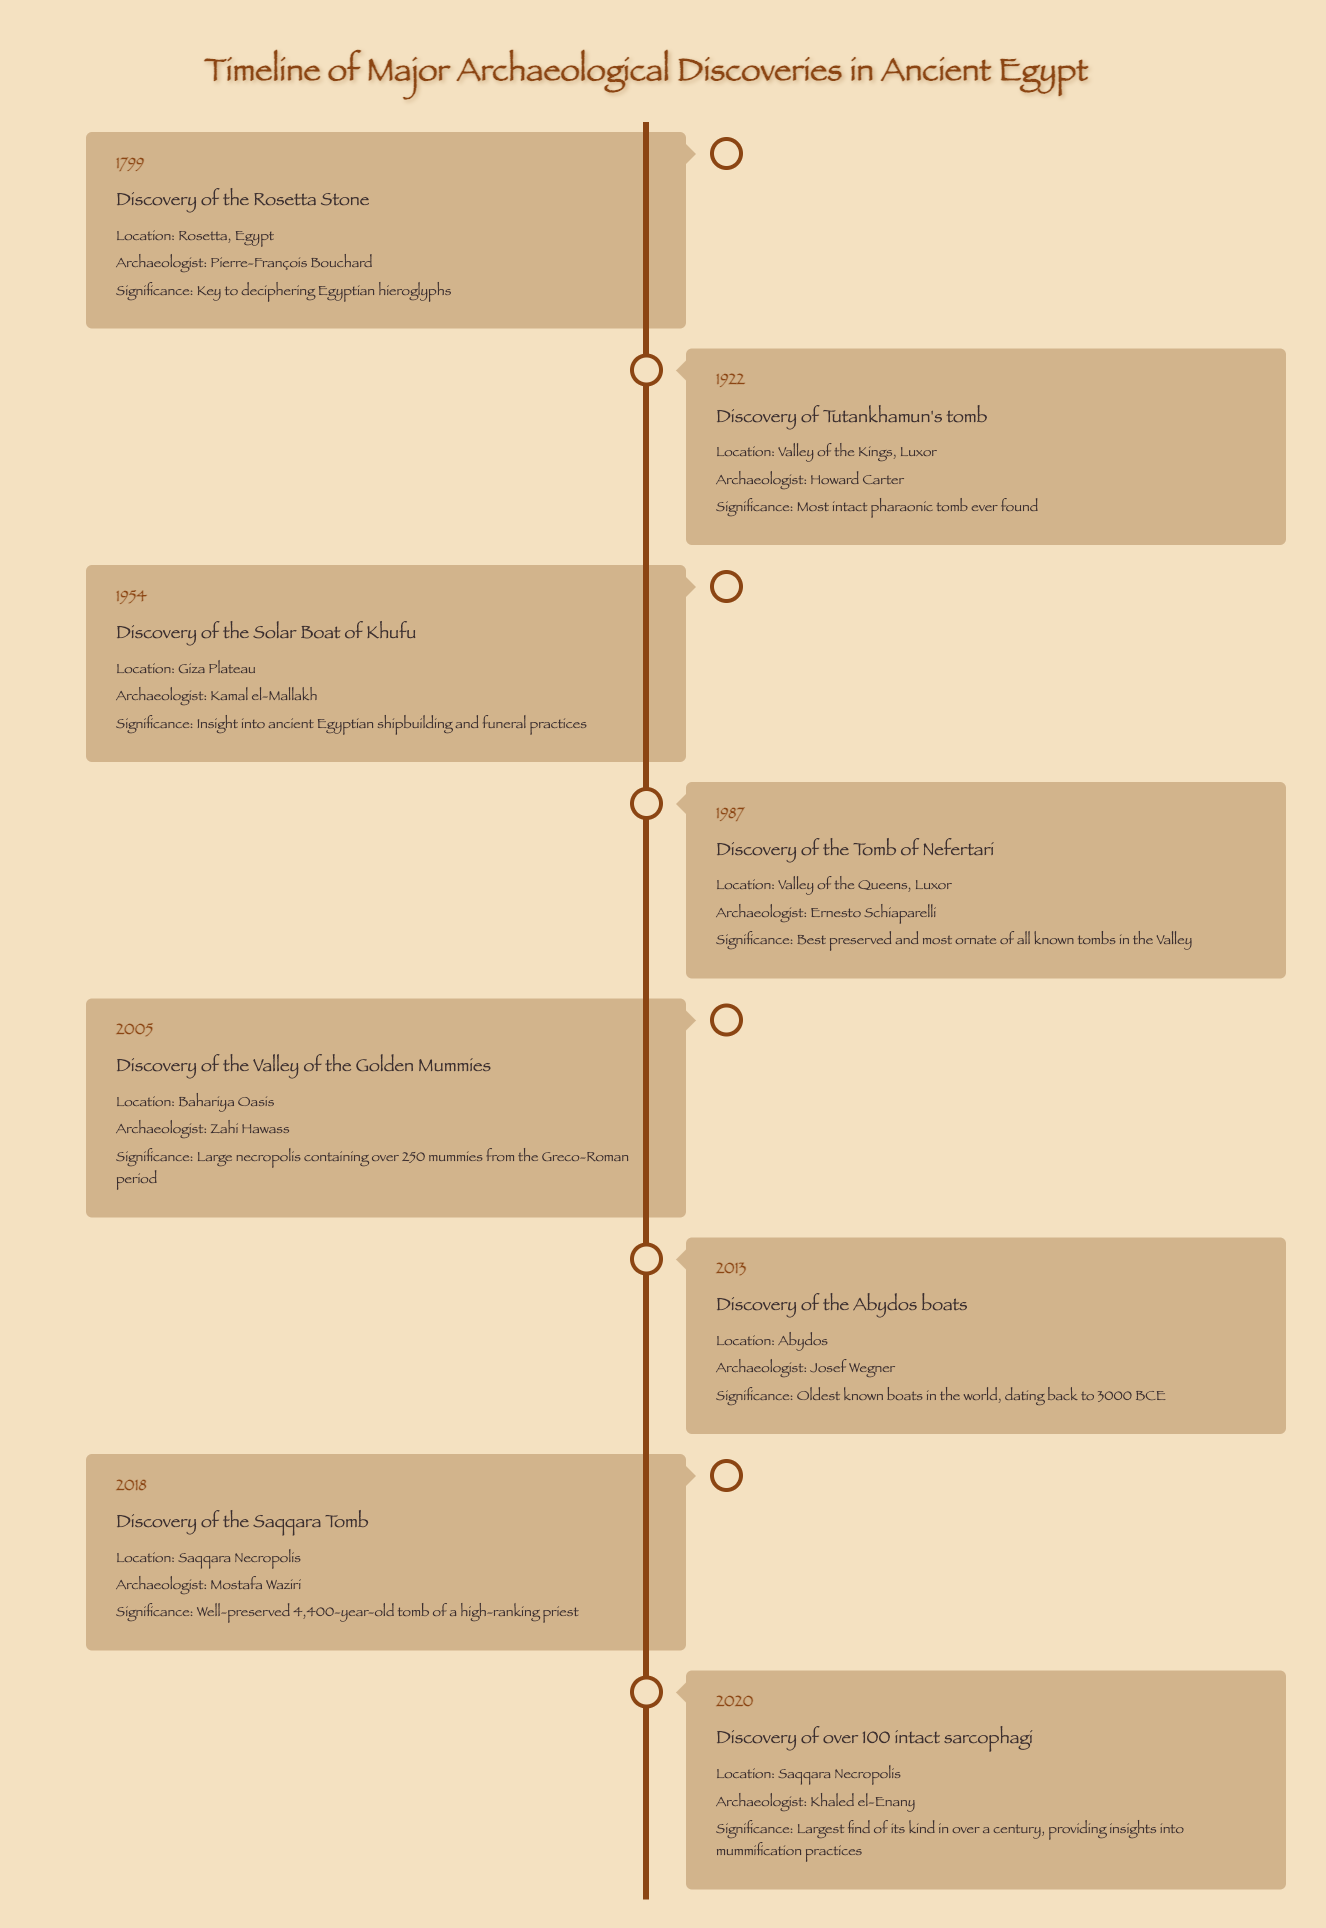What year was the Rosetta Stone discovered? The table indicates that the Rosetta Stone was discovered in the year 1799.
Answer: 1799 Who discovered Tutankhamun's tomb? According to the table, the archaeologist who discovered Tutankhamun's tomb is Howard Carter.
Answer: Howard Carter What significant discovery occurred in 1954? The table lists the discovery of the Solar Boat of Khufu in 1954, which is the significant event for that year.
Answer: Discovery of the Solar Boat of Khufu How many major discoveries occurred before 2000? By counting the entries in the timeline prior to the year 2000, there are 5 major discoveries: 1799, 1922, 1954, 1987, and 2005.
Answer: 5 Was the Valley of the Golden Mummies discovered in the 20th century? The table shows that the Valley of the Golden Mummies was discovered in 2005, which is in the 21st century. Therefore, the answer is no.
Answer: No Which discovery has the significance of providing insights into ancient Egyptian shipbuilding? The table explains that the discovery of the Solar Boat of Khufu in 1954 provided insights into ancient Egyptian shipbuilding and funeral practices.
Answer: Solar Boat of Khufu How many years apart were the discoveries of the Tomb of Nefertari and the Valley of the Golden Mummies? The Tomb of Nefertari was discovered in 1987 and the Valley of the Golden Mummies in 2005. The difference in years is 2005 - 1987 = 18 years.
Answer: 18 years What is the significance of the discovery made in 2013? The discovery made in 2013, noted in the table, was the Abydos boats, which are significant as the oldest known boats in the world, dating back to 3000 BCE.
Answer: Oldest known boats Which two discoveries occurred in the Saqqara Necropolis? Referring to the timeline, the discoveries made in the Saqqara Necropolis were the Saqqara Tomb in 2018 and over 100 intact sarcophagi in 2020.
Answer: Saqqara Tomb and over 100 intact sarcophagi 